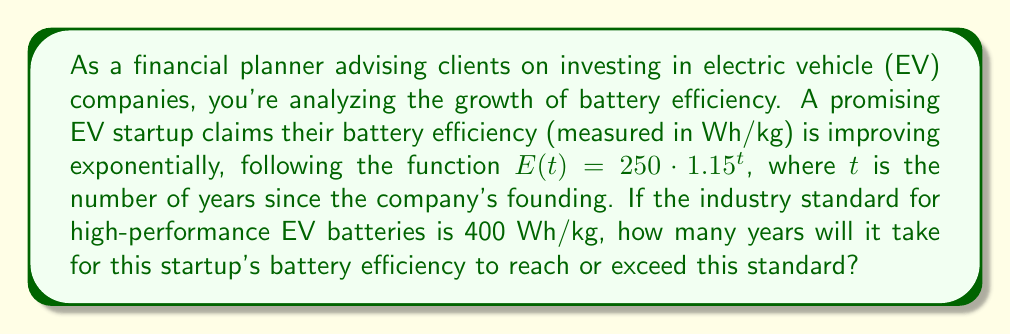Help me with this question. To solve this problem, we need to use logarithms. Let's approach this step-by-step:

1) We're given the function $E(t) = 250 \cdot 1.15^t$

2) We want to find when $E(t) \geq 400$

3) Let's set up the equation:
   $250 \cdot 1.15^t \geq 400$

4) Divide both sides by 250:
   $1.15^t \geq \frac{400}{250} = 1.6$

5) Now we can take the logarithm of both sides. Since the base of the exponential is 1.15, we'll use log base 1.15:
   $\log_{1.15}(1.15^t) \geq \log_{1.15}(1.6)$

6) The left side simplifies to $t$:
   $t \geq \log_{1.15}(1.6)$

7) We can change this to a natural logarithm:
   $t \geq \frac{\ln(1.6)}{\ln(1.15)}$

8) Calculate:
   $t \geq \frac{0.4700036292470837}{0.13976194003760084} \approx 3.36$

9) Since we're dealing with years, we need to round up to the next whole number.
Answer: It will take 4 years for the startup's battery efficiency to reach or exceed the industry standard of 400 Wh/kg. 